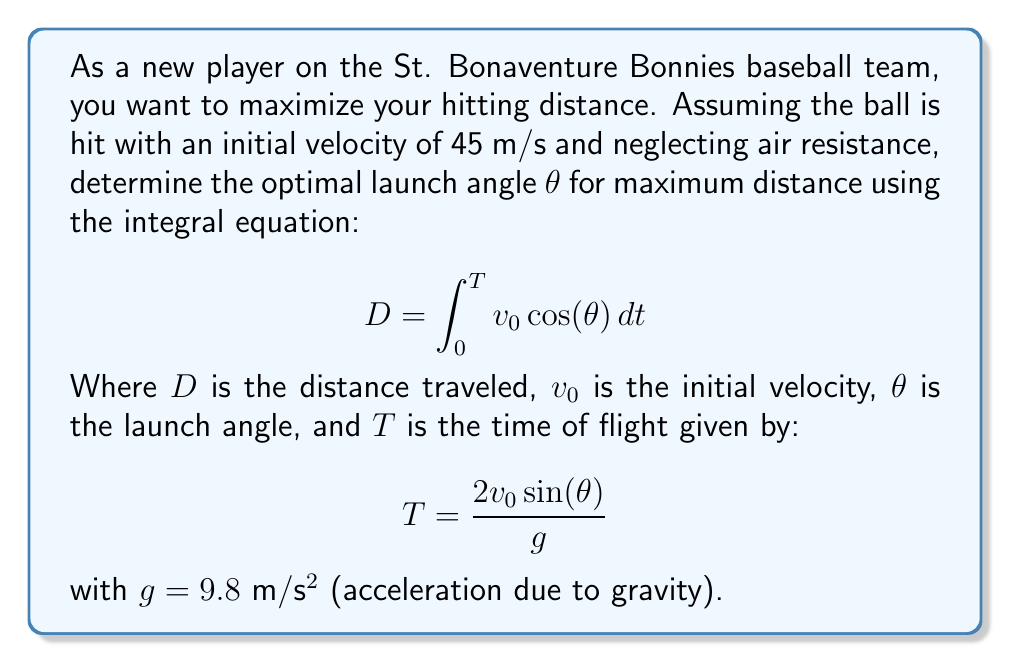Help me with this question. Let's approach this step-by-step:

1) First, we need to express D in terms of θ:
   $$D = v_0 \cos(\theta) \cdot T$$

2) Substitute the expression for T:
   $$D = v_0 \cos(\theta) \cdot \frac{2v_0 \sin(\theta)}{g}$$

3) Simplify:
   $$D = \frac{2v_0^2 \sin(\theta) \cos(\theta)}{g}$$

4) Recall the trigonometric identity: $\sin(2\theta) = 2\sin(\theta)\cos(\theta)$
   So, we can rewrite D as:
   $$D = \frac{v_0^2 \sin(2\theta)}{g}$$

5) To find the maximum distance, we need to maximize $\sin(2\theta)$
   The maximum value of sine is 1, which occurs when its argument is 90°

6) Therefore, for maximum distance:
   $$2\theta = 90°$$
   $$\theta = 45°$$

7) We can verify this by taking the derivative of D with respect to θ, setting it to zero, and solving for θ, but this direct approach using trigonometric properties is simpler.
Answer: 45° 